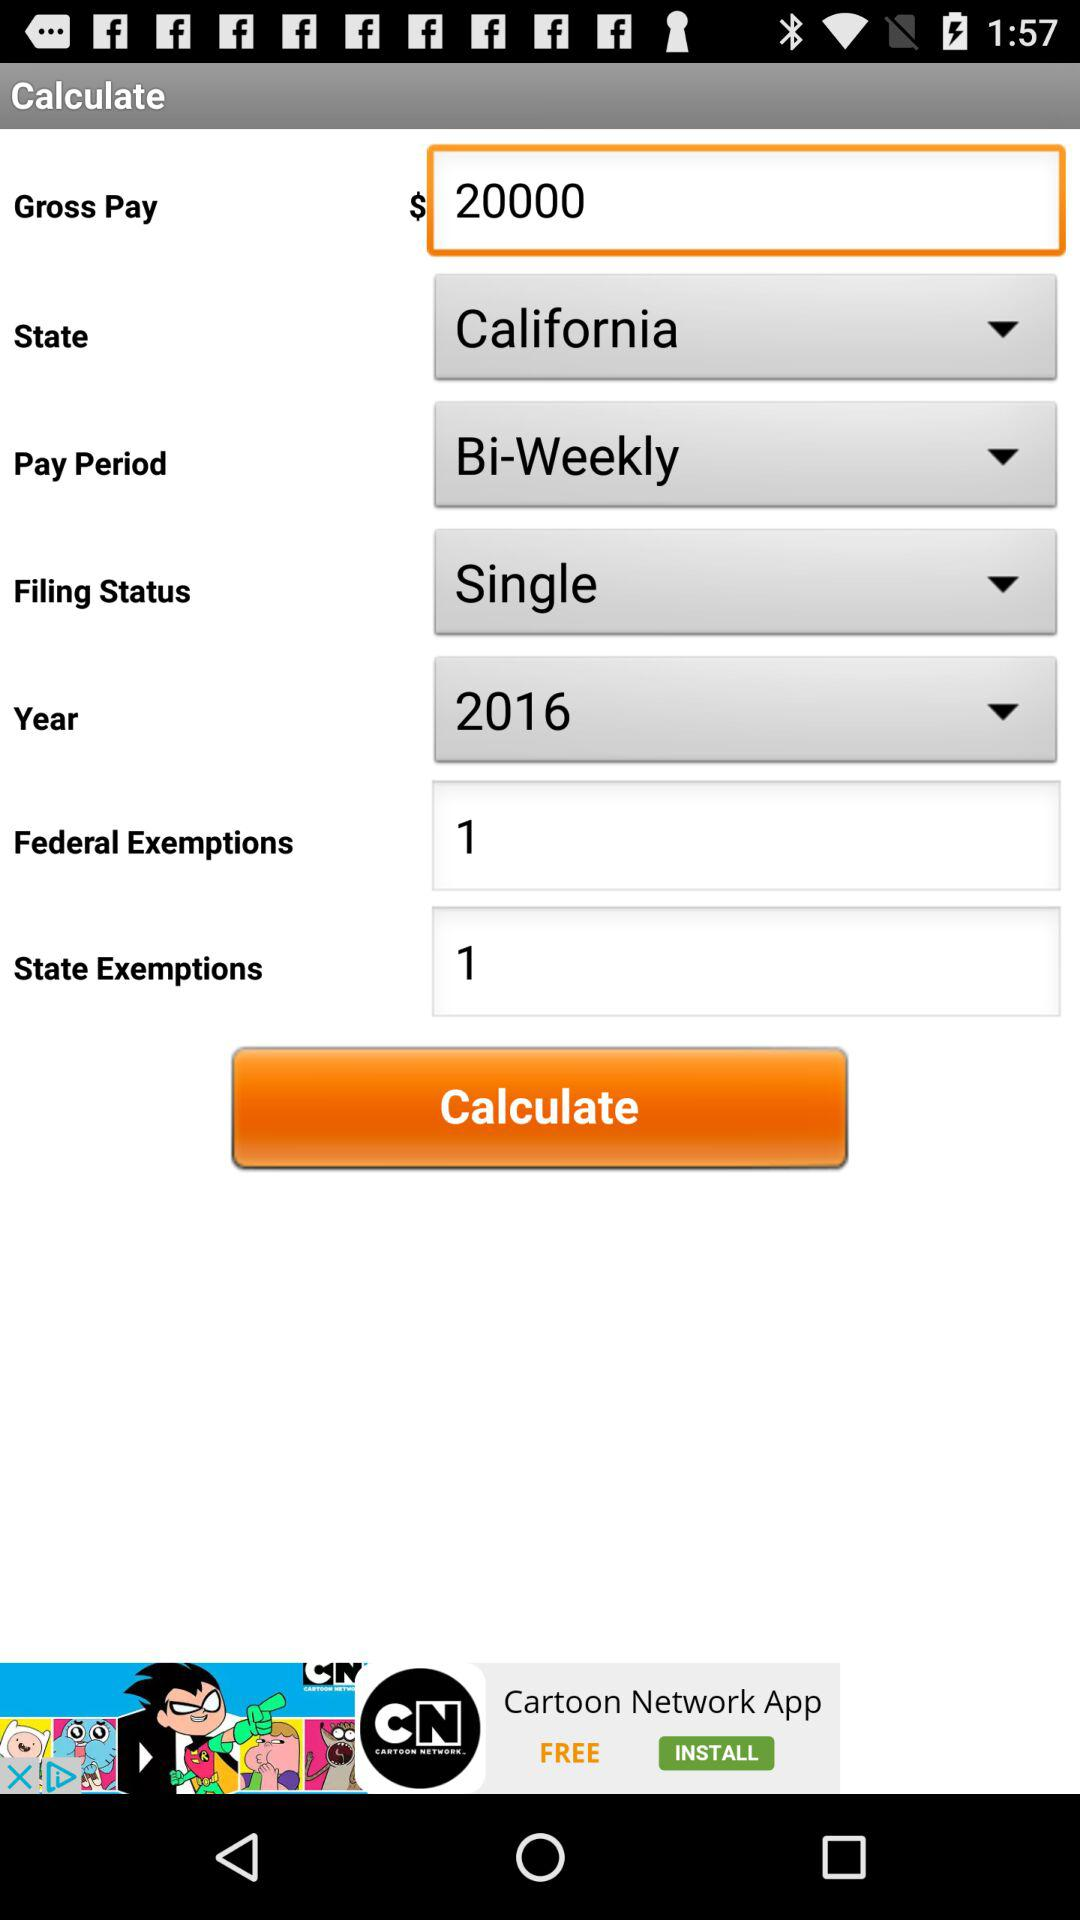Which is the selected state? The selected state is California. 